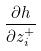Convert formula to latex. <formula><loc_0><loc_0><loc_500><loc_500>\frac { \partial h } { \partial z _ { i } ^ { + } }</formula> 